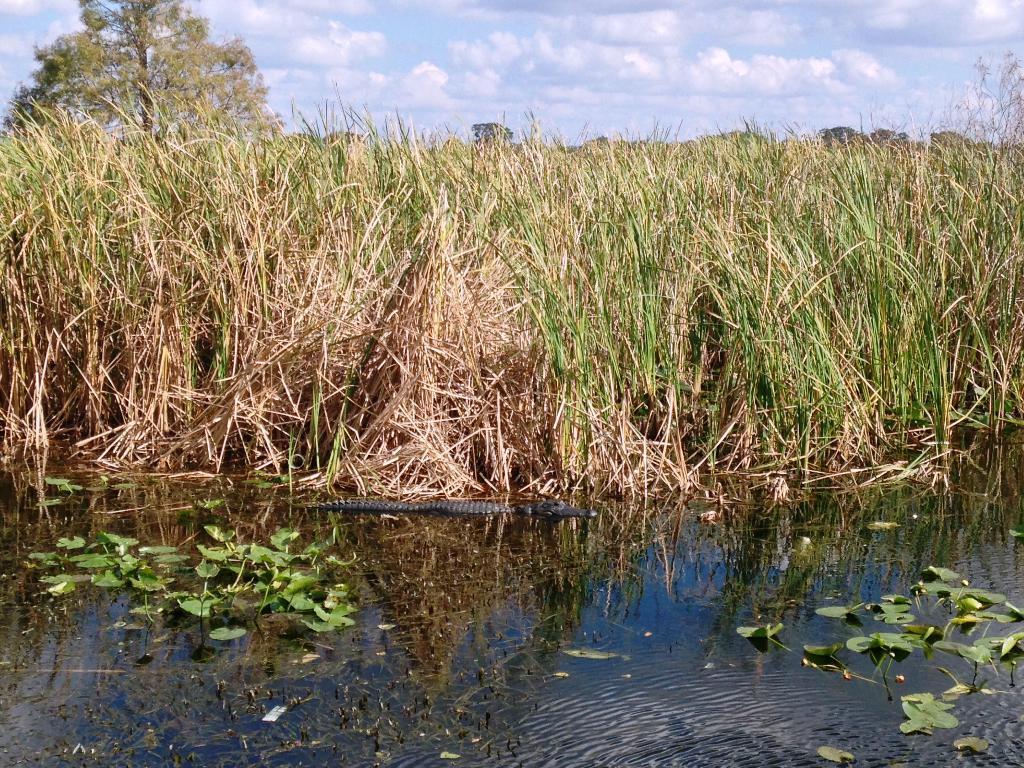Describe this image in one or two sentences. In this image I can water and on it I can see number of green colour leaves. In the background I can see grass, few trees, clouds and the sky. In the centre of this image I can see a black colour thing on the water. 